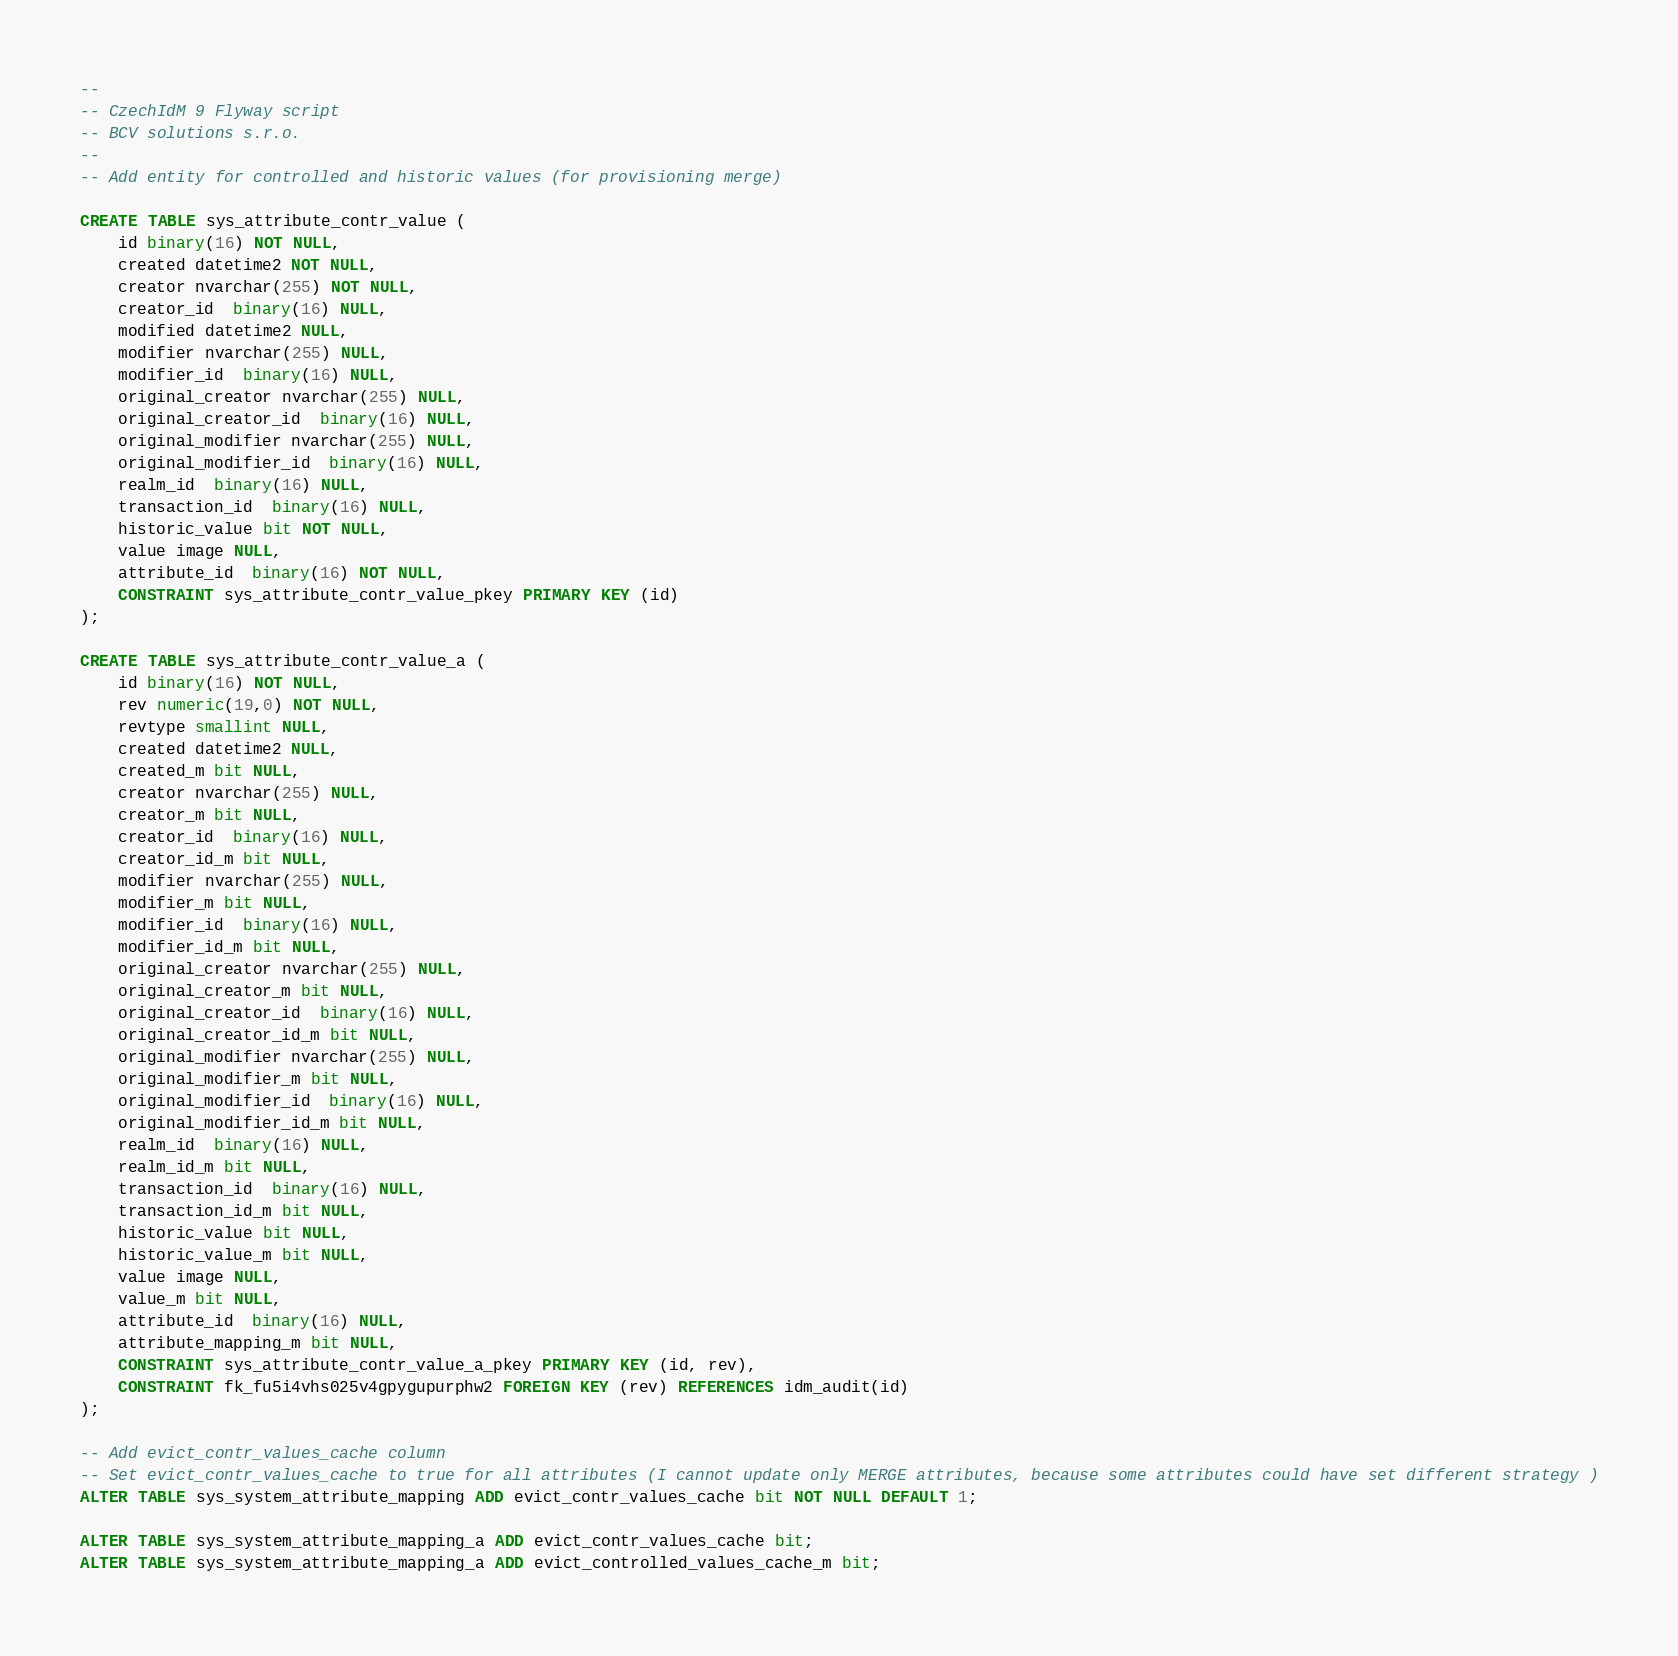<code> <loc_0><loc_0><loc_500><loc_500><_SQL_>--
-- CzechIdM 9 Flyway script 
-- BCV solutions s.r.o.
--
-- Add entity for controlled and historic values (for provisioning merge)

CREATE TABLE sys_attribute_contr_value (
	id binary(16) NOT NULL,
	created datetime2 NOT NULL,
	creator nvarchar(255) NOT NULL,
	creator_id  binary(16) NULL,
	modified datetime2 NULL,
	modifier nvarchar(255) NULL,
	modifier_id  binary(16) NULL,
	original_creator nvarchar(255) NULL,
	original_creator_id  binary(16) NULL,
	original_modifier nvarchar(255) NULL,
	original_modifier_id  binary(16) NULL,
	realm_id  binary(16) NULL,
	transaction_id  binary(16) NULL,
	historic_value bit NOT NULL,
	value image NULL,
	attribute_id  binary(16) NOT NULL,
	CONSTRAINT sys_attribute_contr_value_pkey PRIMARY KEY (id)
);

CREATE TABLE sys_attribute_contr_value_a (
	id binary(16) NOT NULL,
	rev numeric(19,0) NOT NULL,
	revtype smallint NULL,
	created datetime2 NULL,
	created_m bit NULL,
	creator nvarchar(255) NULL,
	creator_m bit NULL,
	creator_id  binary(16) NULL,
	creator_id_m bit NULL,
	modifier nvarchar(255) NULL,
	modifier_m bit NULL,
	modifier_id  binary(16) NULL,
	modifier_id_m bit NULL,
	original_creator nvarchar(255) NULL,
	original_creator_m bit NULL,
	original_creator_id  binary(16) NULL,
	original_creator_id_m bit NULL,
	original_modifier nvarchar(255) NULL,
	original_modifier_m bit NULL,
	original_modifier_id  binary(16) NULL,
	original_modifier_id_m bit NULL,
	realm_id  binary(16) NULL,
	realm_id_m bit NULL,
	transaction_id  binary(16) NULL,
	transaction_id_m bit NULL,
	historic_value bit NULL,
	historic_value_m bit NULL,
	value image NULL,
	value_m bit NULL,
	attribute_id  binary(16) NULL,
	attribute_mapping_m bit NULL,
	CONSTRAINT sys_attribute_contr_value_a_pkey PRIMARY KEY (id, rev),
	CONSTRAINT fk_fu5i4vhs025v4gpygupurphw2 FOREIGN KEY (rev) REFERENCES idm_audit(id)
);

-- Add evict_contr_values_cache column
-- Set evict_contr_values_cache to true for all attributes (I cannot update only MERGE attributes, because some attributes could have set different strategy )
ALTER TABLE sys_system_attribute_mapping ADD evict_contr_values_cache bit NOT NULL DEFAULT 1;

ALTER TABLE sys_system_attribute_mapping_a ADD evict_contr_values_cache bit;
ALTER TABLE sys_system_attribute_mapping_a ADD evict_controlled_values_cache_m bit;

</code> 